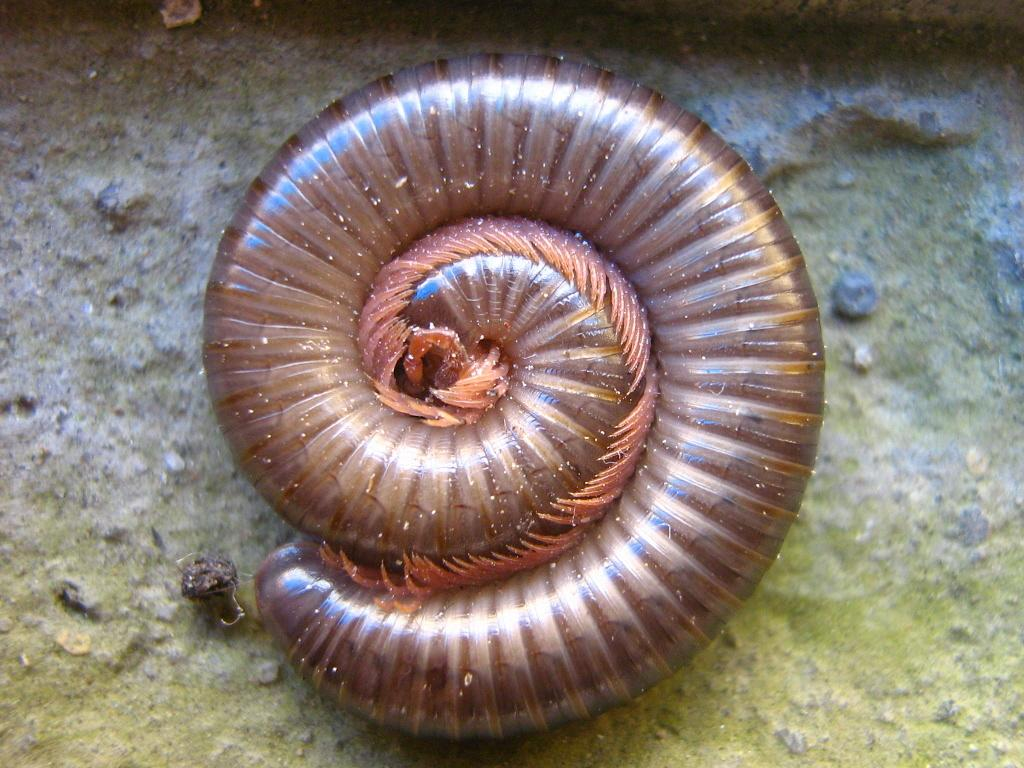What type of creature is in the image? There is a millipede in the image. How is the millipede positioned in the image? The millipede is curled. What color is the millipede? The millipede is brown in color. How many kittens are playing with the mitten in the image? There are no kittens or mittens present in the image; it features a millipede. 